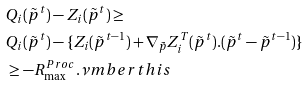Convert formula to latex. <formula><loc_0><loc_0><loc_500><loc_500>& Q _ { i } ( \tilde { p } ^ { t } ) - Z _ { i } ( \tilde { p } ^ { t } ) \geq & & & & \\ & Q _ { i } ( \tilde { p } ^ { t } ) - \{ Z _ { i } ( \tilde { p } ^ { t - 1 } ) + \nabla _ { \tilde { p } } Z ^ { T } _ { i } ( \tilde { p } ^ { t } ) . ( \tilde { p } ^ { t } - \tilde { p } ^ { t - 1 } ) \} & & \\ & \geq - R _ { \max } ^ { P r o c } . \nu m b e r t h i s</formula> 